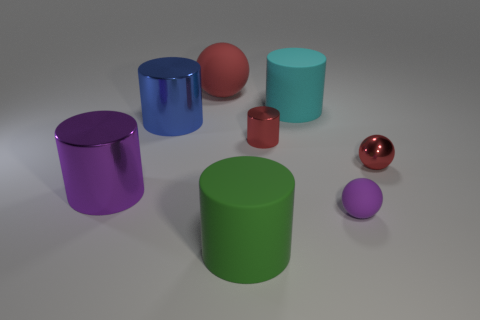The tiny purple rubber object has what shape? Upon closer inspection, the tiny purple object appears to be spherical, resembling a small rubber ball. 